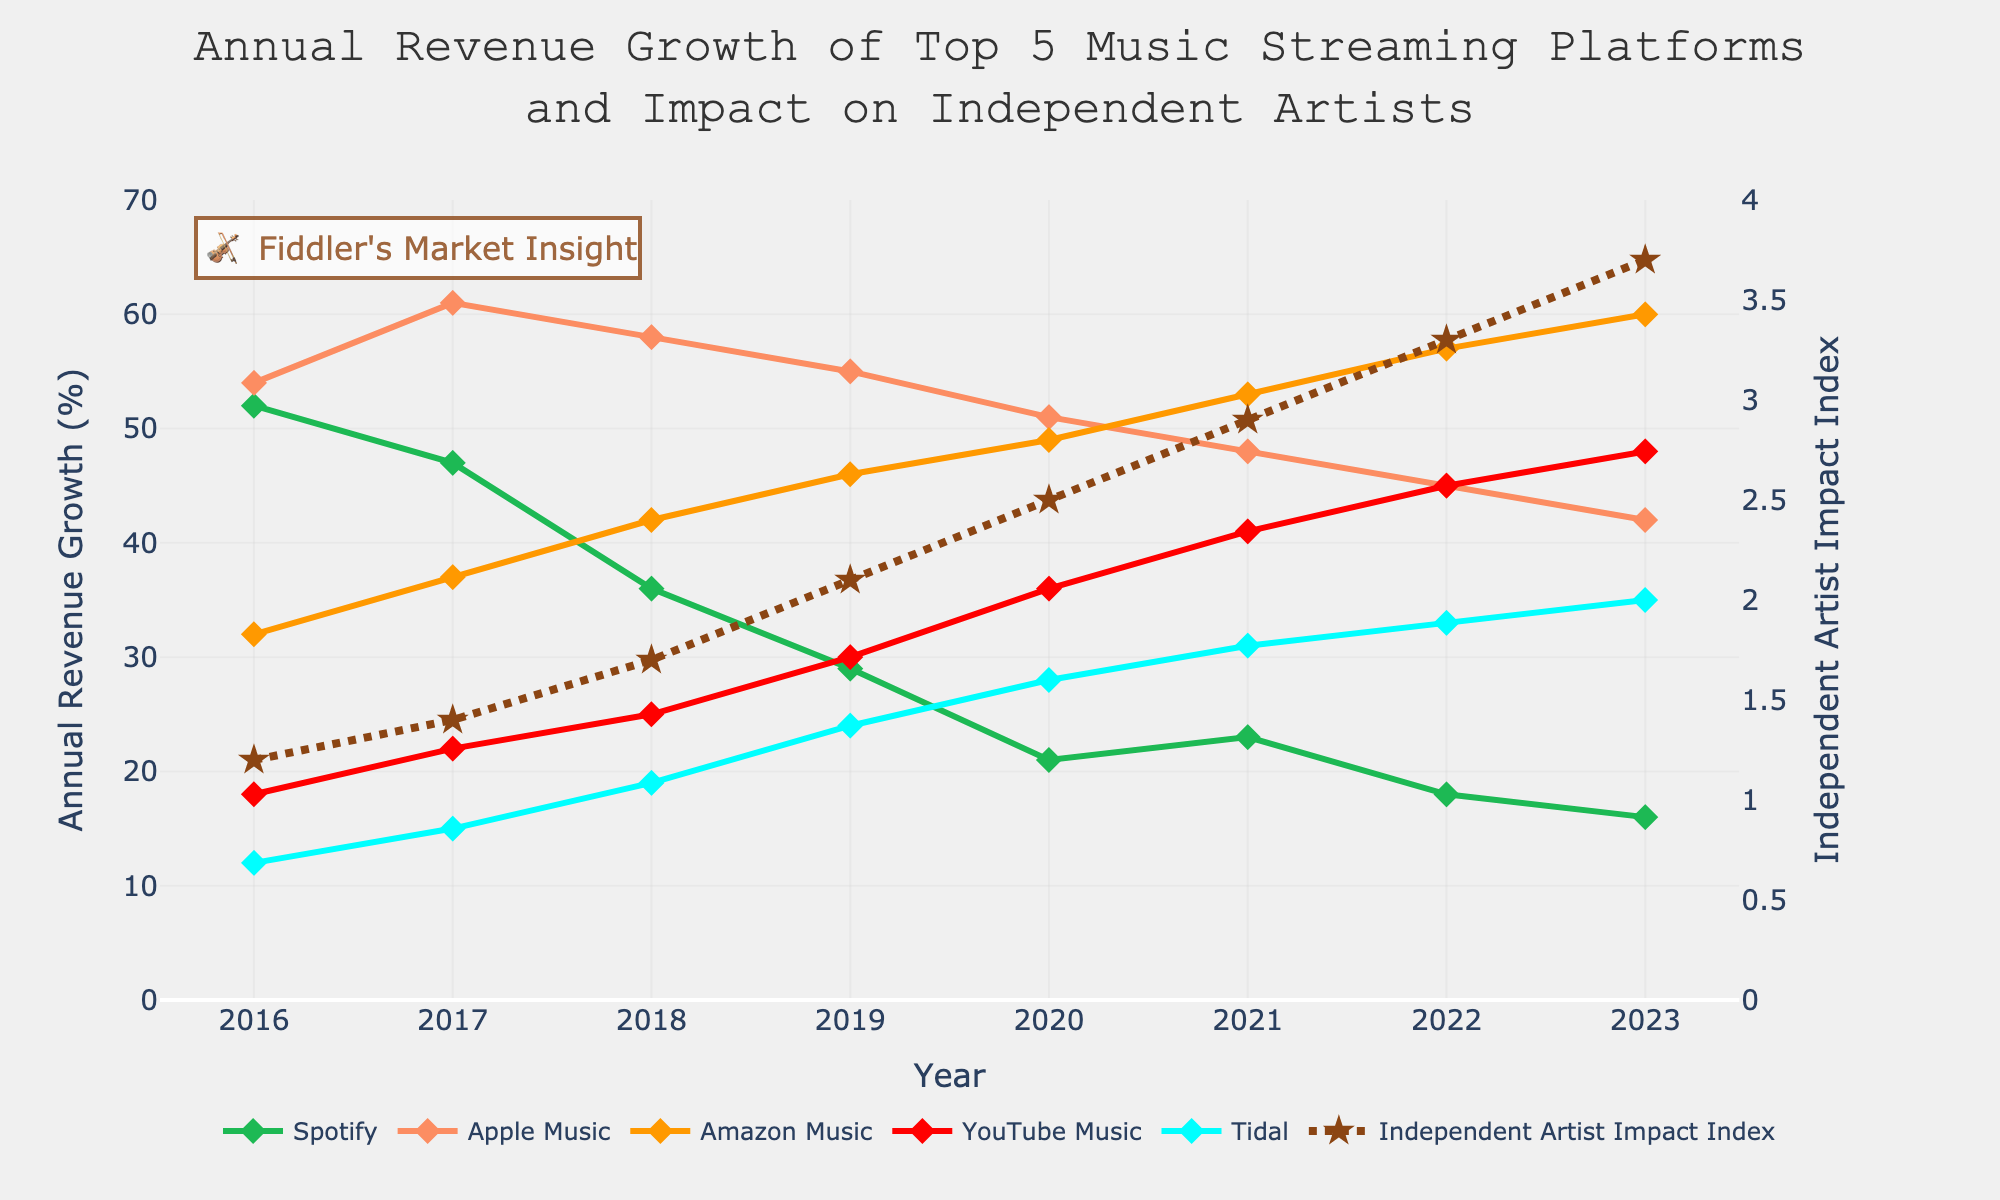Which platform had the highest revenue growth in 2021? Look at the line chart, and identify the highest data point in 2021. Apple Music had the highest value at 48%.
Answer: Apple Music What's the overall trend of the Independent Artist Impact Index from 2016 to 2023? Check the line representing the Independent Artist Impact Index, noting whether it generally increases, decreases, or remains stable over the years. The index consistently increases from 1.2 in 2016 to 3.7 in 2023.
Answer: Increasing How did Spotify's revenue growth change from 2016 to 2023? Observe the line representing Spotify's revenue growth from 2016 to 2023. Spotify’s revenue growth declined from 52% in 2016 to 16% in 2023.
Answer: Declined Between which years did YouTube Music see the most significant increase in revenue growth? Look for the steepest climb in YouTube Music's line. The most significant increase is between 2019 (30%) and 2020 (36%).
Answer: 2019 to 2020 In which year were Spotify and Tidal's revenue growth most similar? Compare the lines of Spotify and Tidal year by year to find the smallest difference. Spotify and Tidal's revenue growth were closest in 2023, at 16% and 35% respectively.
Answer: 2023 Which year shows the biggest difference in annual revenue growth between Apple Music and Amazon Music? Find the years when lines for Apple Music and Amazon Music are farthest apart. In 2016, Apple Music had 54% and Amazon Music had 32%, a difference of 22%.
Answer: 2016 What is the difference in the Independent Artist Impact Index between 2016 and 2023? Subtract the index value in 2016 from the index value in 2023, which is \(3.7 - 1.2 = 2.5\).
Answer: 2.5 Which platform had a decreasing trend in revenue growth over the entire period? Look for lines that show a downward trend from 2016 to 2023. Spotify consistently shows a downward trend in revenue growth.
Answer: Spotify How does the revenue growth for YouTube Music in 2023 compare to the Independent Artist Impact Index in the same year? Directly compare the values of both: YouTube Music has a revenue growth of 48%, while the Independent Artist Impact Index is at 3.7.
Answer: YouTube Music is higher Between 2019 and 2023, which platform had the most consistent revenue growth? Look for the platform line with the least fluctuation between 2019 and 2023. Apple Music shows the most consistent values from 55% to 42%.
Answer: Apple Music 